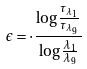<formula> <loc_0><loc_0><loc_500><loc_500>\epsilon = \cdot \frac { \log \frac { \tau _ { \lambda _ { 1 } } } { \tau _ { \lambda _ { 9 } } } } { \log \frac { \lambda _ { 1 } } { \lambda _ { 9 } } }</formula> 